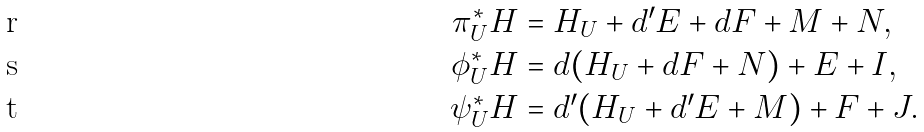<formula> <loc_0><loc_0><loc_500><loc_500>\pi _ { U } ^ { * } H & = H _ { U } + d ^ { \prime } E + d F + M + N , \\ \phi _ { U } ^ { * } H & = d ( H _ { U } + d F + N ) + E + I , \\ \psi _ { U } ^ { * } H & = d ^ { \prime } ( H _ { U } + d ^ { \prime } E + M ) + F + J .</formula> 